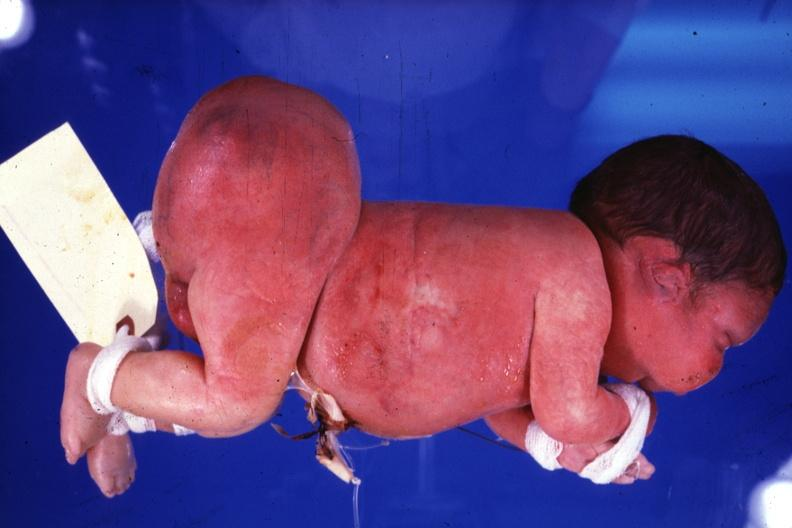does mesothelioma show lateral view of body with grossly enlarged buttocks area?
Answer the question using a single word or phrase. No 